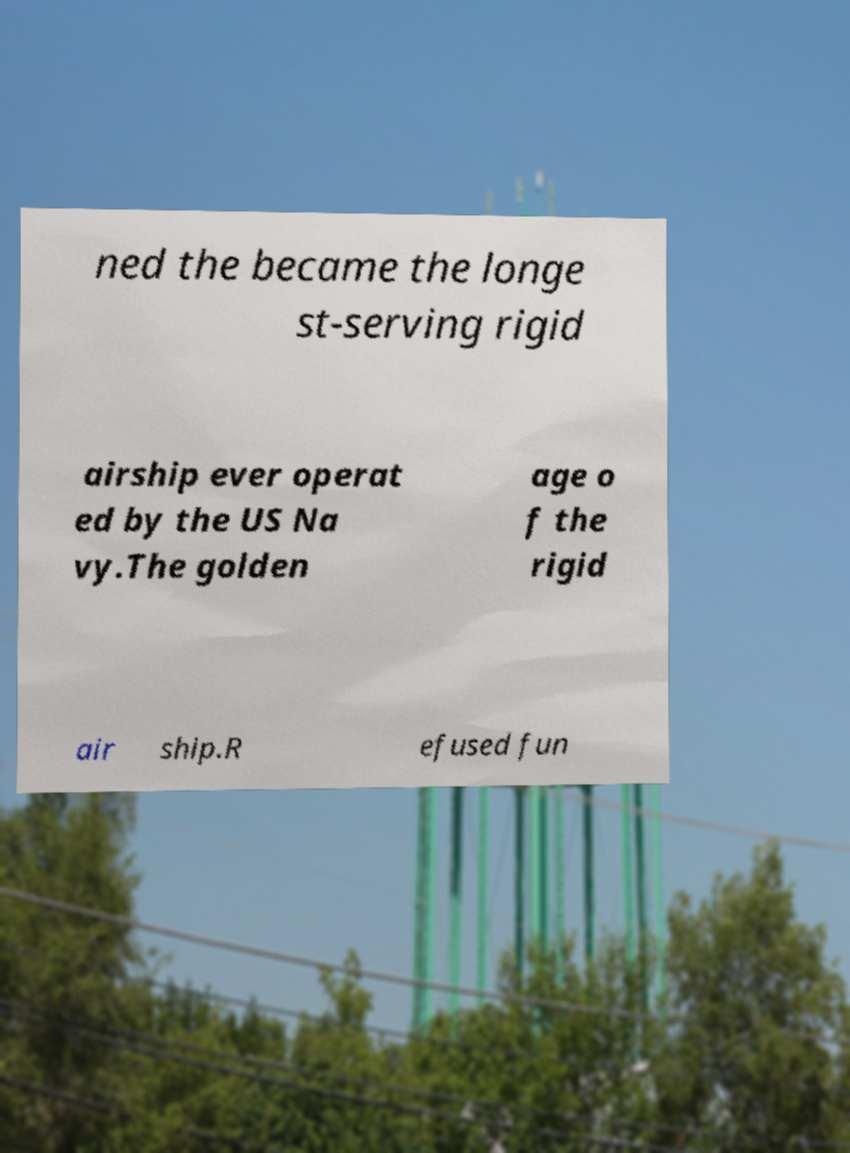Can you accurately transcribe the text from the provided image for me? ned the became the longe st-serving rigid airship ever operat ed by the US Na vy.The golden age o f the rigid air ship.R efused fun 